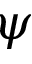<formula> <loc_0><loc_0><loc_500><loc_500>\psi</formula> 